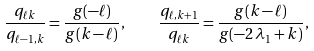Convert formula to latex. <formula><loc_0><loc_0><loc_500><loc_500>\frac { q _ { \ell k } } { q _ { \ell - 1 , k } } = \frac { g ( - \ell ) } { g ( k - \ell ) } , \quad \frac { q _ { \ell , k + 1 } } { q _ { \ell k } } = \frac { g ( k - \ell ) } { g ( - 2 \, \lambda _ { 1 } + k ) } ,</formula> 